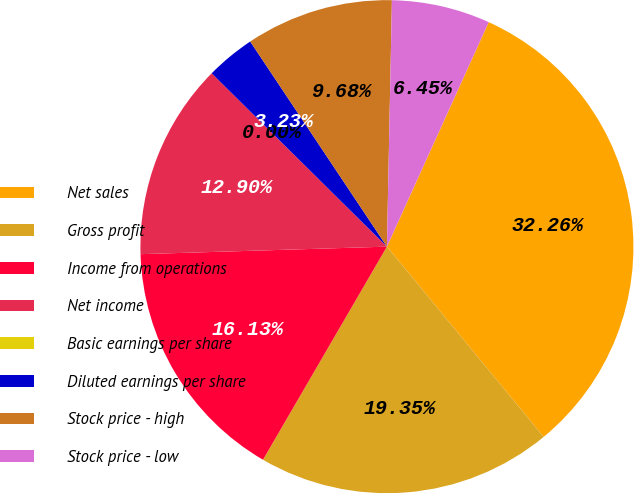<chart> <loc_0><loc_0><loc_500><loc_500><pie_chart><fcel>Net sales<fcel>Gross profit<fcel>Income from operations<fcel>Net income<fcel>Basic earnings per share<fcel>Diluted earnings per share<fcel>Stock price - high<fcel>Stock price - low<nl><fcel>32.26%<fcel>19.35%<fcel>16.13%<fcel>12.9%<fcel>0.0%<fcel>3.23%<fcel>9.68%<fcel>6.45%<nl></chart> 